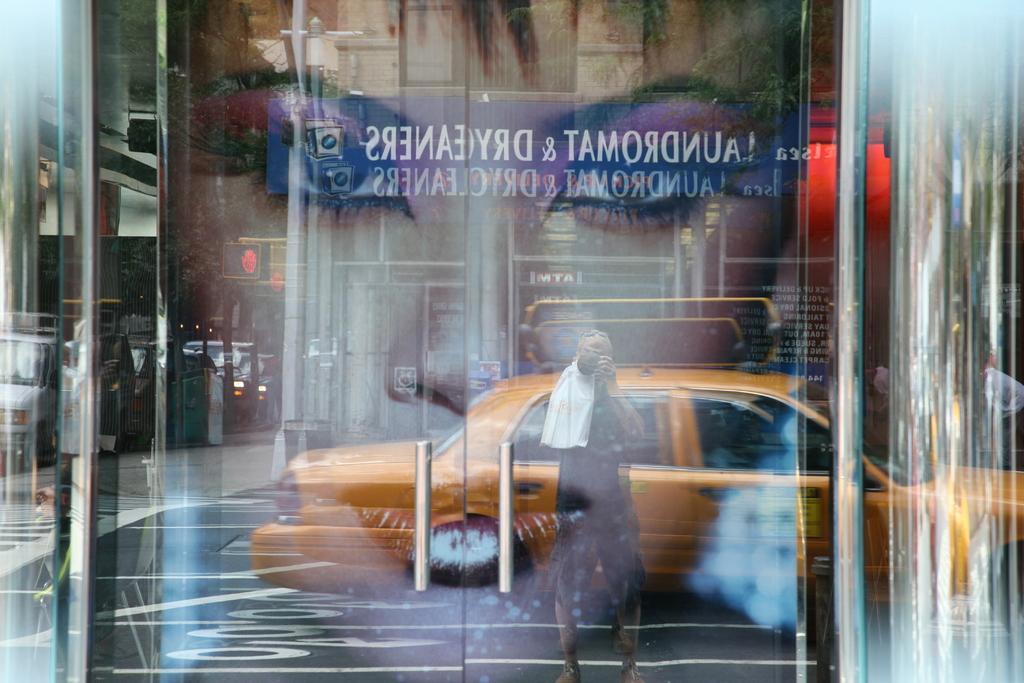In one or two sentences, can you explain what this image depicts? There is a glass door which has a picture of a person and a car on it. 